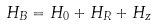Convert formula to latex. <formula><loc_0><loc_0><loc_500><loc_500>H _ { B } = H _ { 0 } + H _ { R } + H _ { z }</formula> 